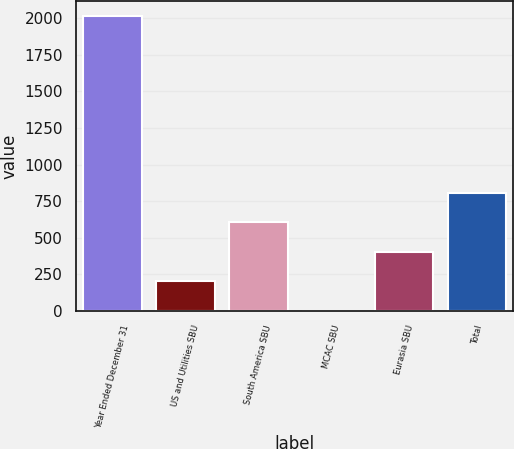<chart> <loc_0><loc_0><loc_500><loc_500><bar_chart><fcel>Year Ended December 31<fcel>US and Utilities SBU<fcel>South America SBU<fcel>MCAC SBU<fcel>Eurasia SBU<fcel>Total<nl><fcel>2016<fcel>202.5<fcel>605.5<fcel>1<fcel>404<fcel>807<nl></chart> 